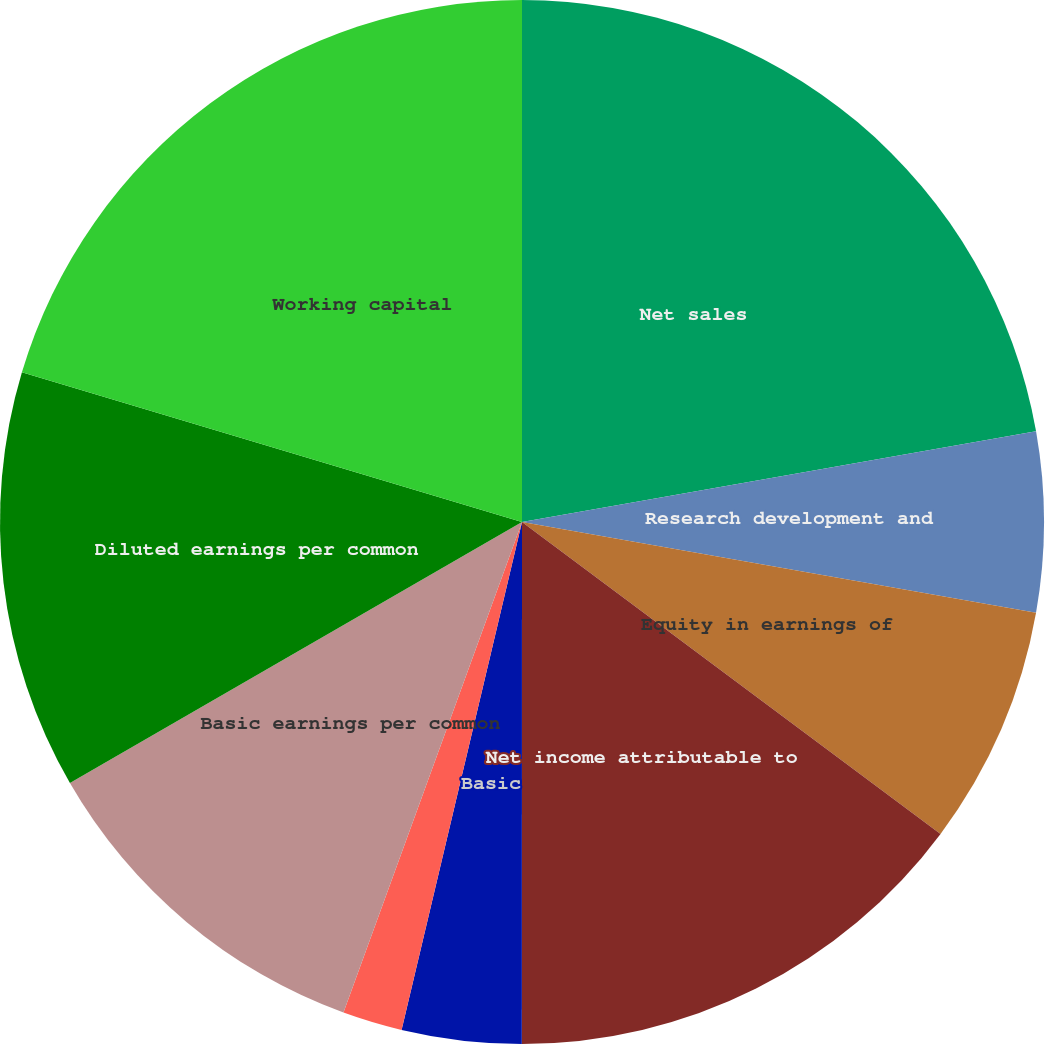<chart> <loc_0><loc_0><loc_500><loc_500><pie_chart><fcel>Net sales<fcel>Research development and<fcel>Equity in earnings of<fcel>Net income attributable to<fcel>Basic<fcel>Diluted<fcel>Cash dividends declared per<fcel>Basic earnings per common<fcel>Diluted earnings per common<fcel>Working capital<nl><fcel>22.22%<fcel>5.56%<fcel>7.41%<fcel>14.81%<fcel>3.7%<fcel>1.85%<fcel>0.0%<fcel>11.11%<fcel>12.96%<fcel>20.37%<nl></chart> 